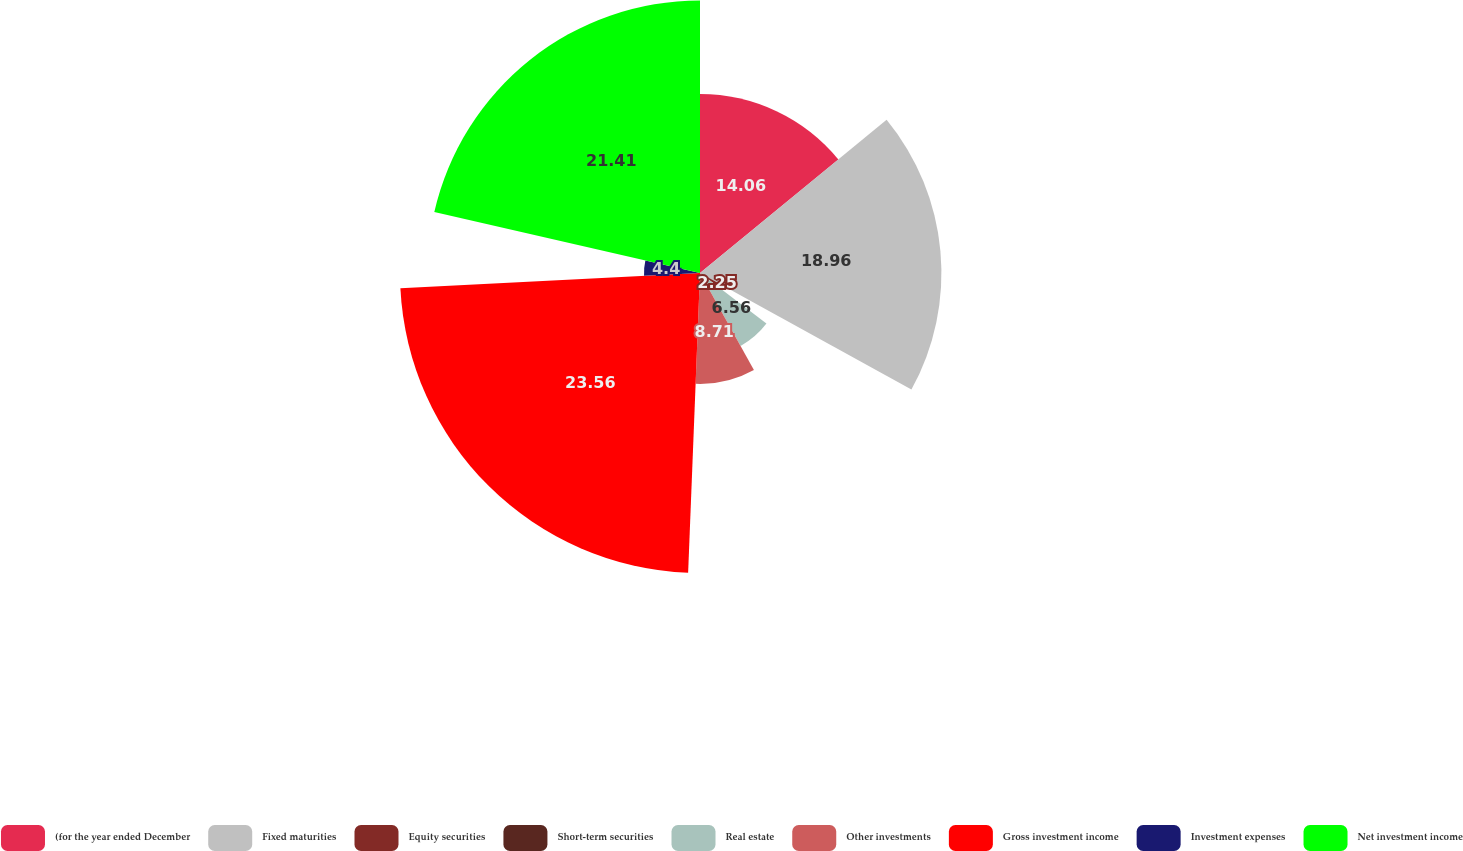Convert chart to OTSL. <chart><loc_0><loc_0><loc_500><loc_500><pie_chart><fcel>(for the year ended December<fcel>Fixed maturities<fcel>Equity securities<fcel>Short-term securities<fcel>Real estate<fcel>Other investments<fcel>Gross investment income<fcel>Investment expenses<fcel>Net investment income<nl><fcel>14.06%<fcel>18.96%<fcel>2.25%<fcel>0.09%<fcel>6.56%<fcel>8.71%<fcel>23.56%<fcel>4.4%<fcel>21.41%<nl></chart> 